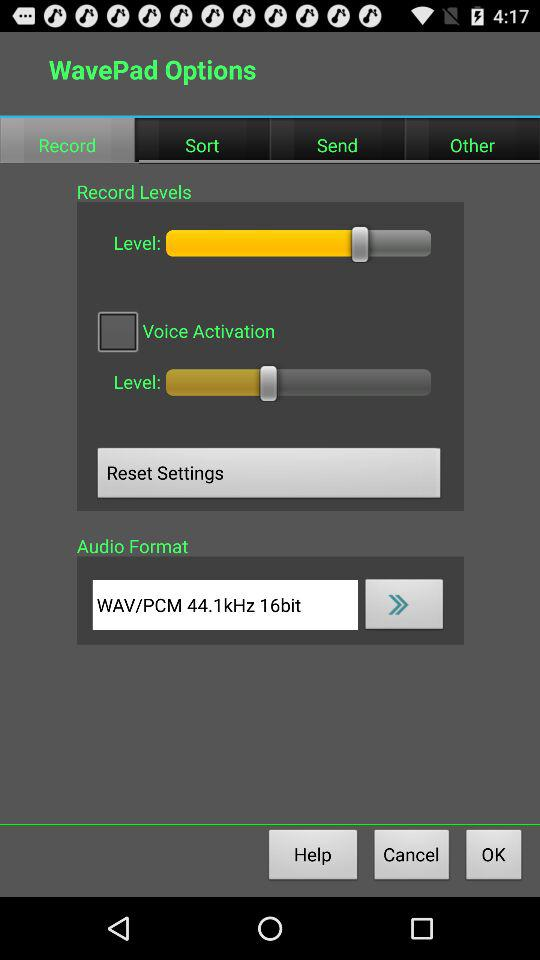What is the status of "Voice Activation"? The status is "off". 